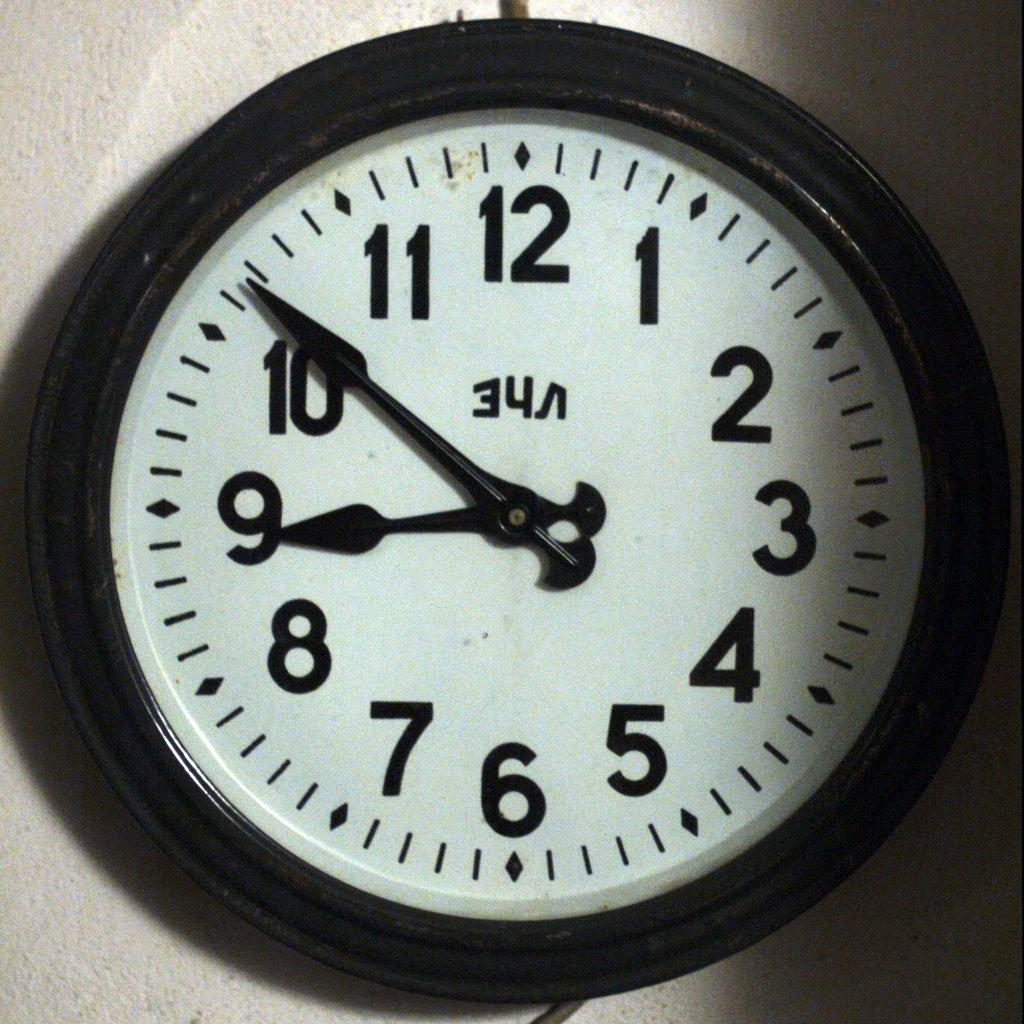Provide a one-sentence caption for the provided image. A black and white wall clock that shows a time of 8:51. 